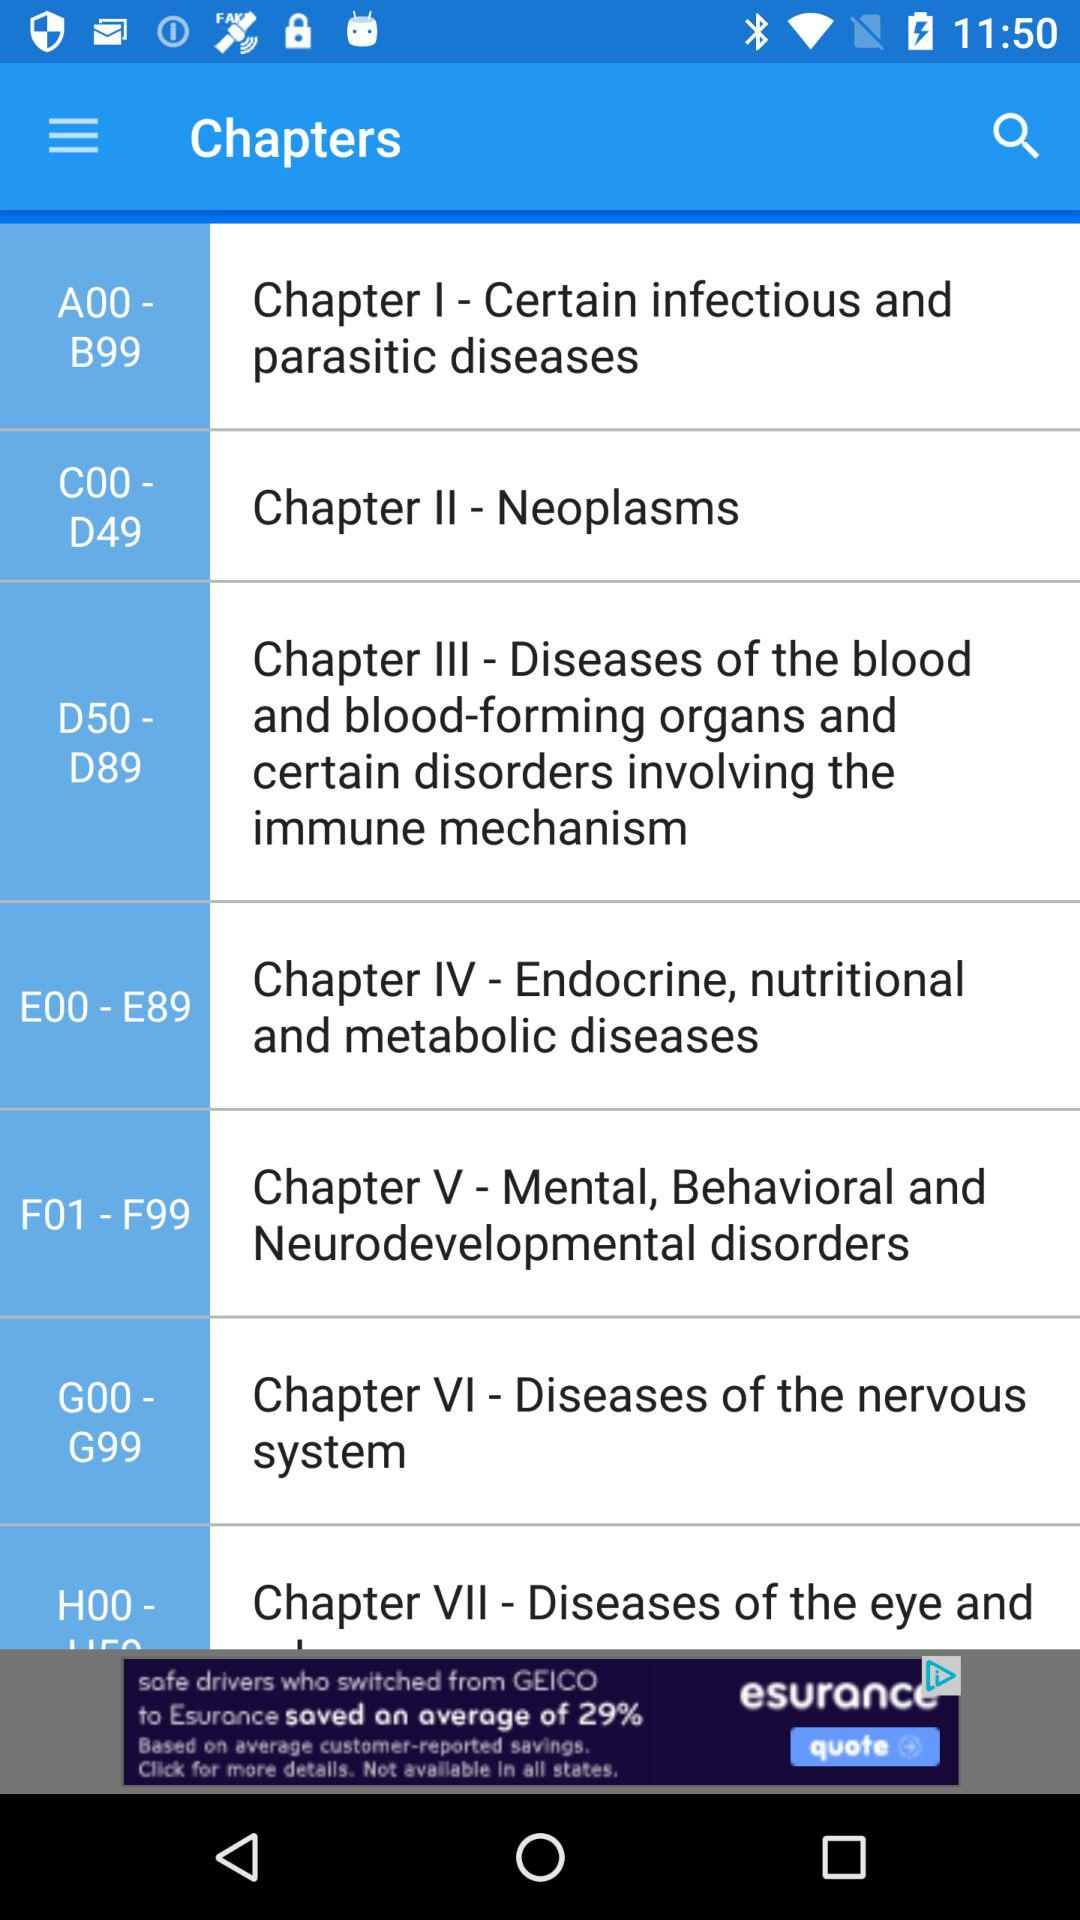What topic is covered in chapter 2? The topic is "Neoplasms". 